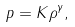<formula> <loc_0><loc_0><loc_500><loc_500>p = K \rho ^ { \gamma } ,</formula> 